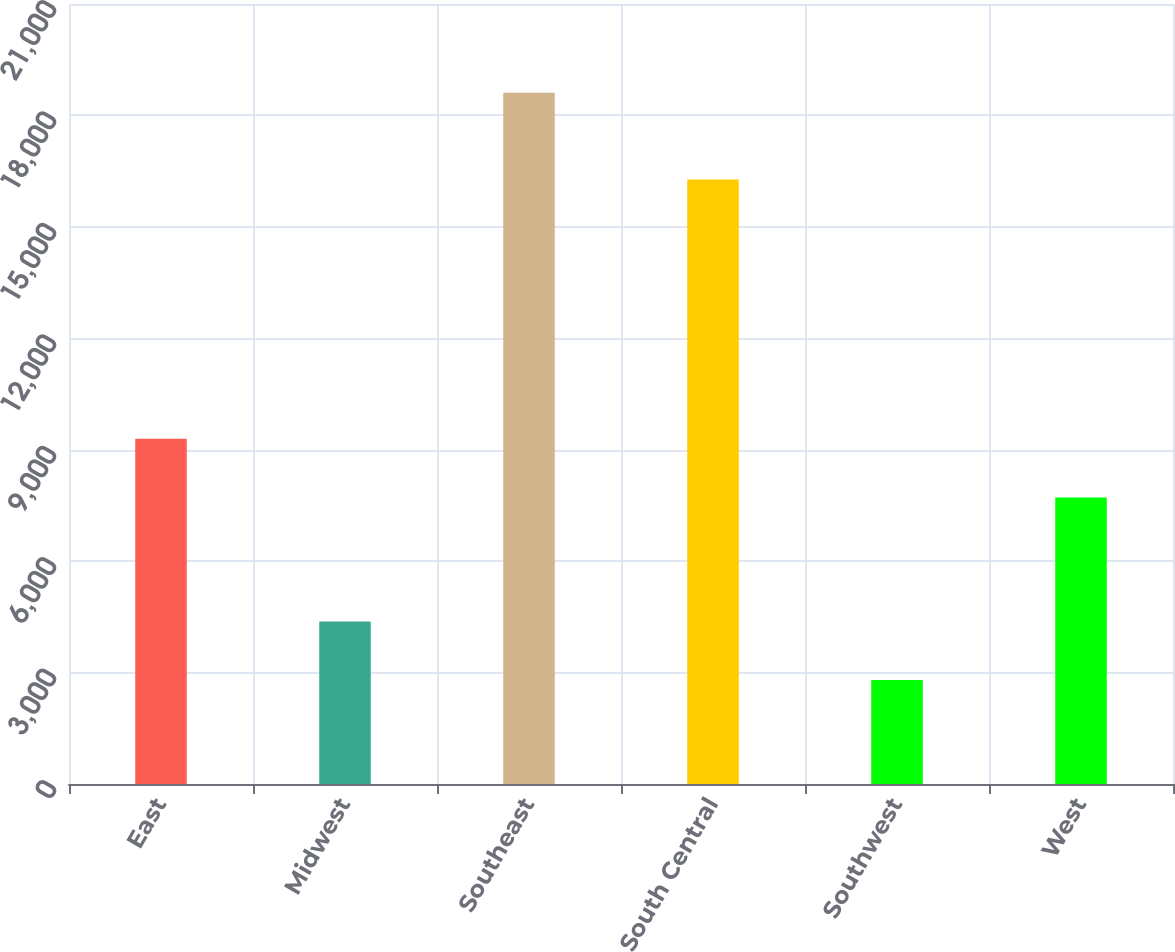<chart> <loc_0><loc_0><loc_500><loc_500><bar_chart><fcel>East<fcel>Midwest<fcel>Southeast<fcel>South Central<fcel>Southwest<fcel>West<nl><fcel>9297.2<fcel>4378.2<fcel>18609<fcel>16278<fcel>2797<fcel>7716<nl></chart> 